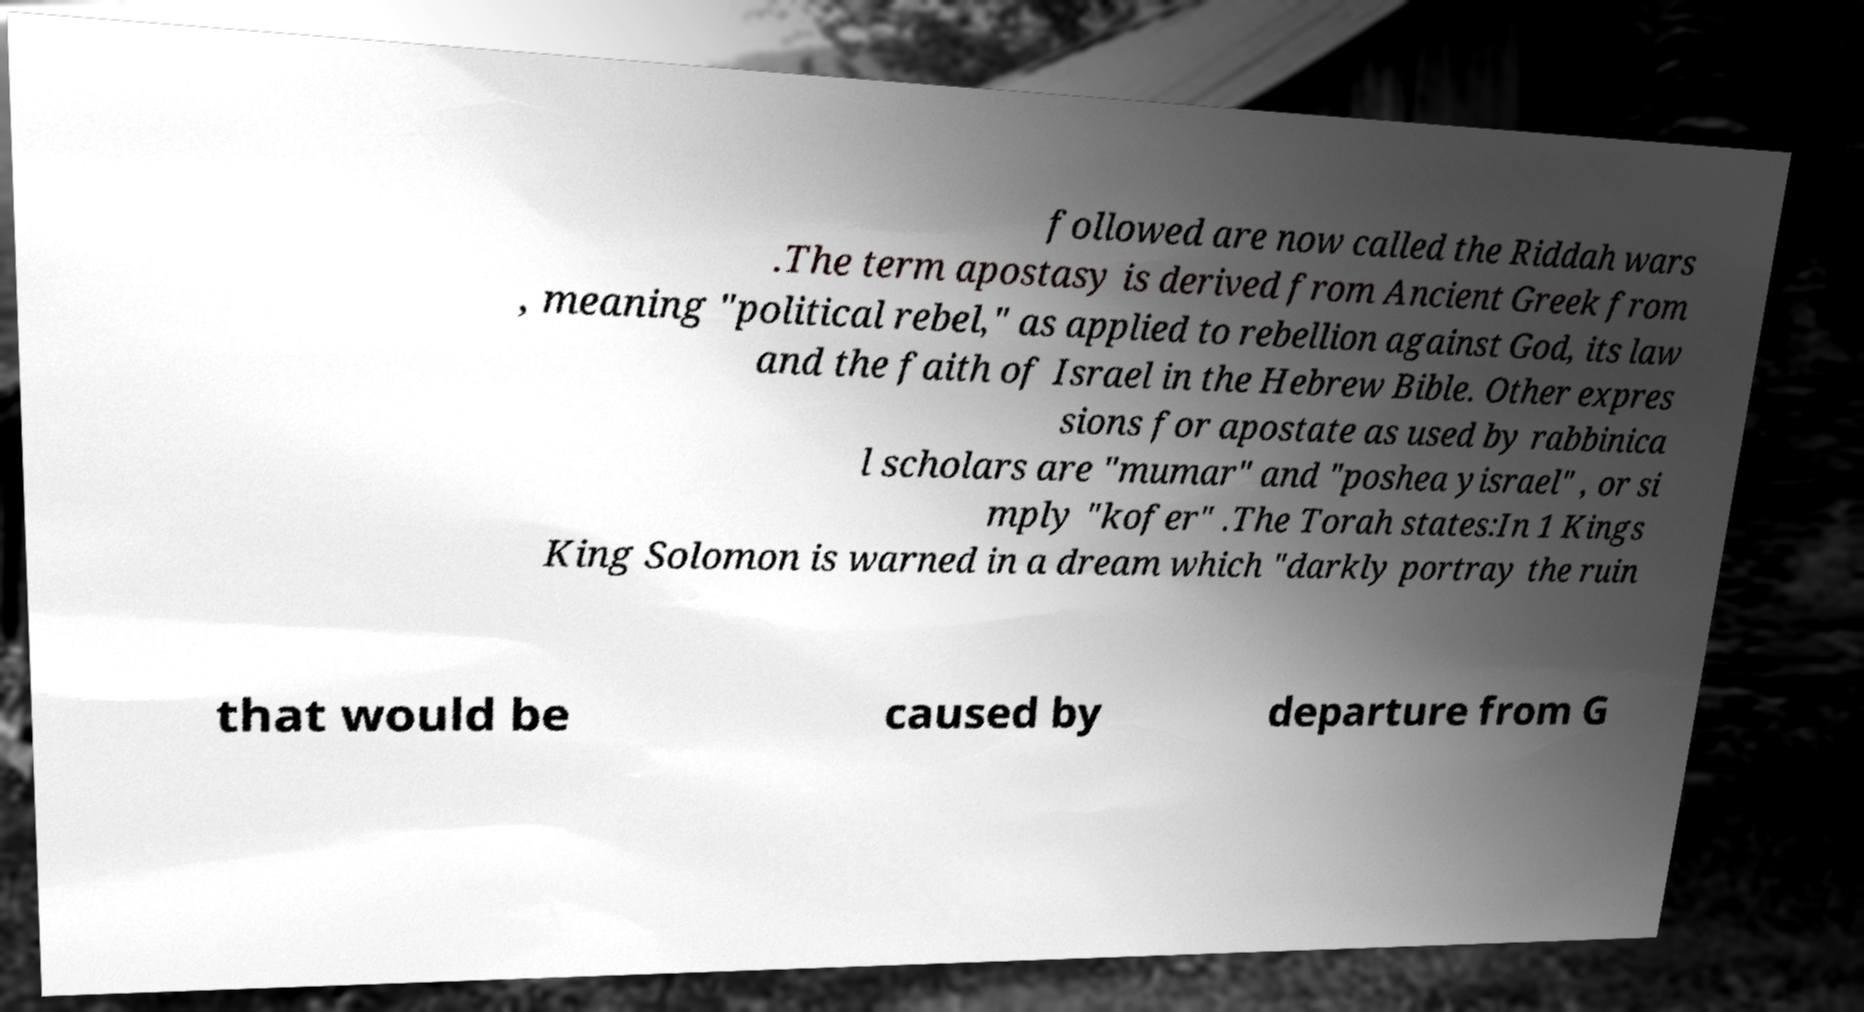Please identify and transcribe the text found in this image. followed are now called the Riddah wars .The term apostasy is derived from Ancient Greek from , meaning "political rebel," as applied to rebellion against God, its law and the faith of Israel in the Hebrew Bible. Other expres sions for apostate as used by rabbinica l scholars are "mumar" and "poshea yisrael" , or si mply "kofer" .The Torah states:In 1 Kings King Solomon is warned in a dream which "darkly portray the ruin that would be caused by departure from G 